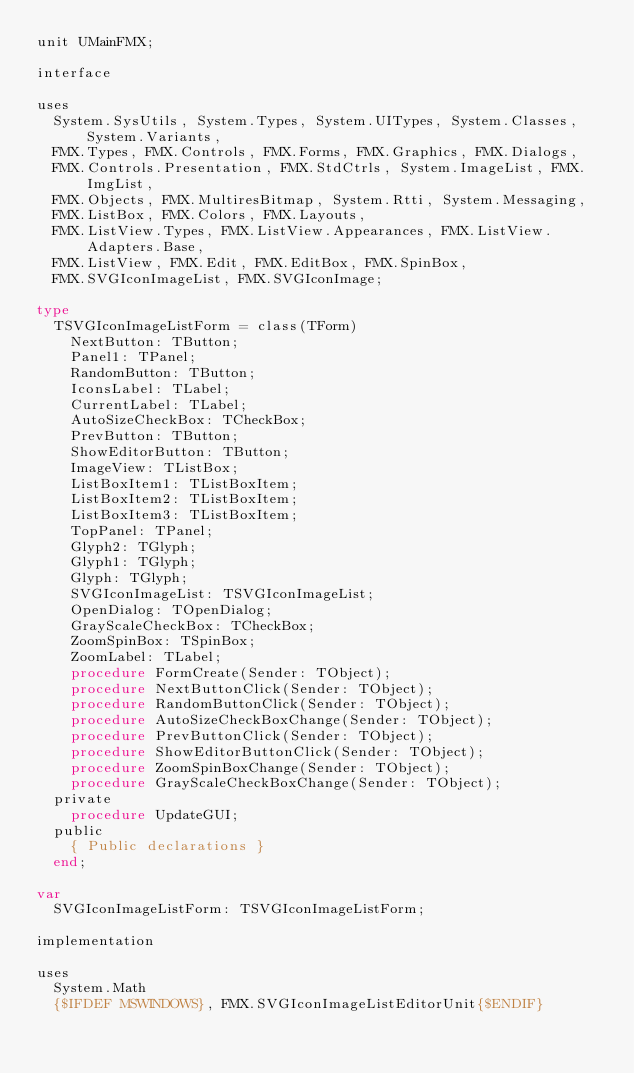<code> <loc_0><loc_0><loc_500><loc_500><_Pascal_>unit UMainFMX;

interface

uses
  System.SysUtils, System.Types, System.UITypes, System.Classes, System.Variants,
  FMX.Types, FMX.Controls, FMX.Forms, FMX.Graphics, FMX.Dialogs,
  FMX.Controls.Presentation, FMX.StdCtrls, System.ImageList, FMX.ImgList,
  FMX.Objects, FMX.MultiresBitmap, System.Rtti, System.Messaging,
  FMX.ListBox, FMX.Colors, FMX.Layouts,
  FMX.ListView.Types, FMX.ListView.Appearances, FMX.ListView.Adapters.Base,
  FMX.ListView, FMX.Edit, FMX.EditBox, FMX.SpinBox,
  FMX.SVGIconImageList, FMX.SVGIconImage;

type
  TSVGIconImageListForm = class(TForm)
    NextButton: TButton;
    Panel1: TPanel;
    RandomButton: TButton;
    IconsLabel: TLabel;
    CurrentLabel: TLabel;
    AutoSizeCheckBox: TCheckBox;
    PrevButton: TButton;
    ShowEditorButton: TButton;
    ImageView: TListBox;
    ListBoxItem1: TListBoxItem;
    ListBoxItem2: TListBoxItem;
    ListBoxItem3: TListBoxItem;
    TopPanel: TPanel;
    Glyph2: TGlyph;
    Glyph1: TGlyph;
    Glyph: TGlyph;
    SVGIconImageList: TSVGIconImageList;
    OpenDialog: TOpenDialog;
    GrayScaleCheckBox: TCheckBox;
    ZoomSpinBox: TSpinBox;
    ZoomLabel: TLabel;
    procedure FormCreate(Sender: TObject);
    procedure NextButtonClick(Sender: TObject);
    procedure RandomButtonClick(Sender: TObject);
    procedure AutoSizeCheckBoxChange(Sender: TObject);
    procedure PrevButtonClick(Sender: TObject);
    procedure ShowEditorButtonClick(Sender: TObject);
    procedure ZoomSpinBoxChange(Sender: TObject);
    procedure GrayScaleCheckBoxChange(Sender: TObject);
  private
    procedure UpdateGUI;
  public
    { Public declarations }
  end;

var
  SVGIconImageListForm: TSVGIconImageListForm;

implementation

uses
  System.Math
  {$IFDEF MSWINDOWS}, FMX.SVGIconImageListEditorUnit{$ENDIF}</code> 